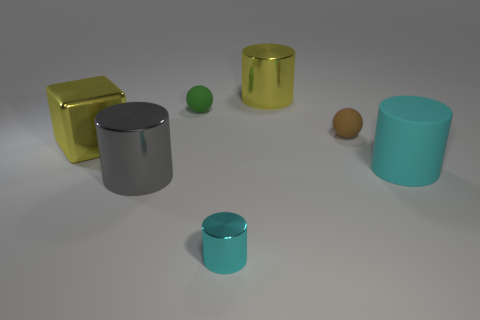Add 2 big yellow rubber objects. How many objects exist? 9 Subtract all spheres. How many objects are left? 5 Subtract all gray cylinders. Subtract all tiny rubber things. How many objects are left? 4 Add 1 tiny rubber things. How many tiny rubber things are left? 3 Add 7 red matte blocks. How many red matte blocks exist? 7 Subtract 1 yellow blocks. How many objects are left? 6 